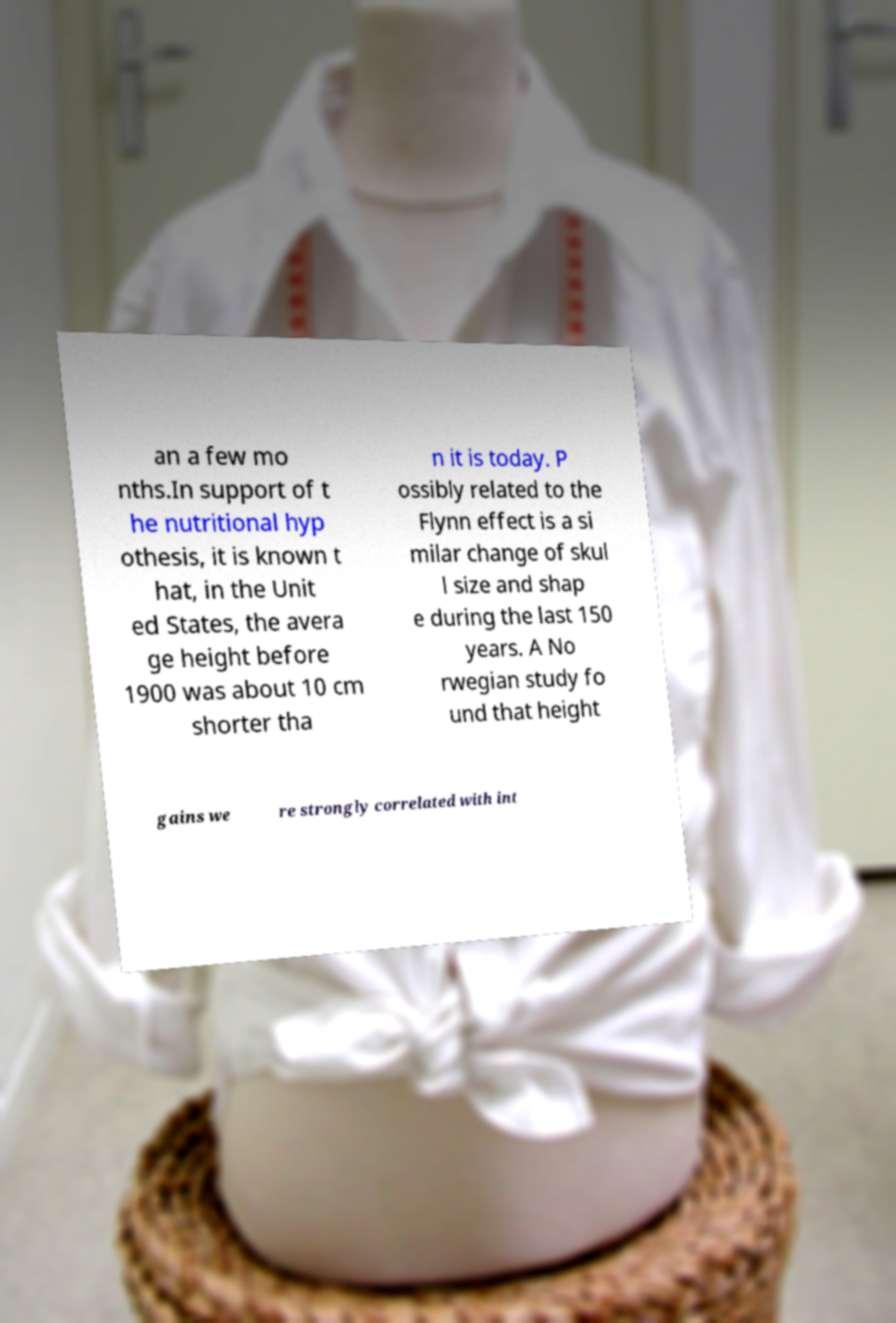Please identify and transcribe the text found in this image. an a few mo nths.In support of t he nutritional hyp othesis, it is known t hat, in the Unit ed States, the avera ge height before 1900 was about 10 cm shorter tha n it is today. P ossibly related to the Flynn effect is a si milar change of skul l size and shap e during the last 150 years. A No rwegian study fo und that height gains we re strongly correlated with int 